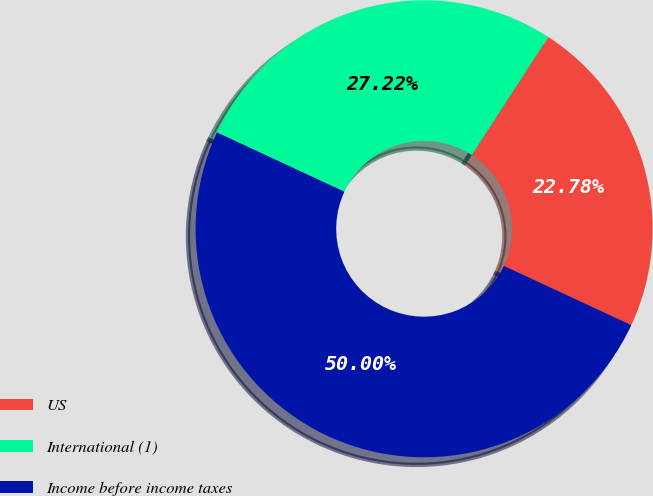<chart> <loc_0><loc_0><loc_500><loc_500><pie_chart><fcel>US<fcel>International (1)<fcel>Income before income taxes<nl><fcel>22.78%<fcel>27.22%<fcel>50.0%<nl></chart> 